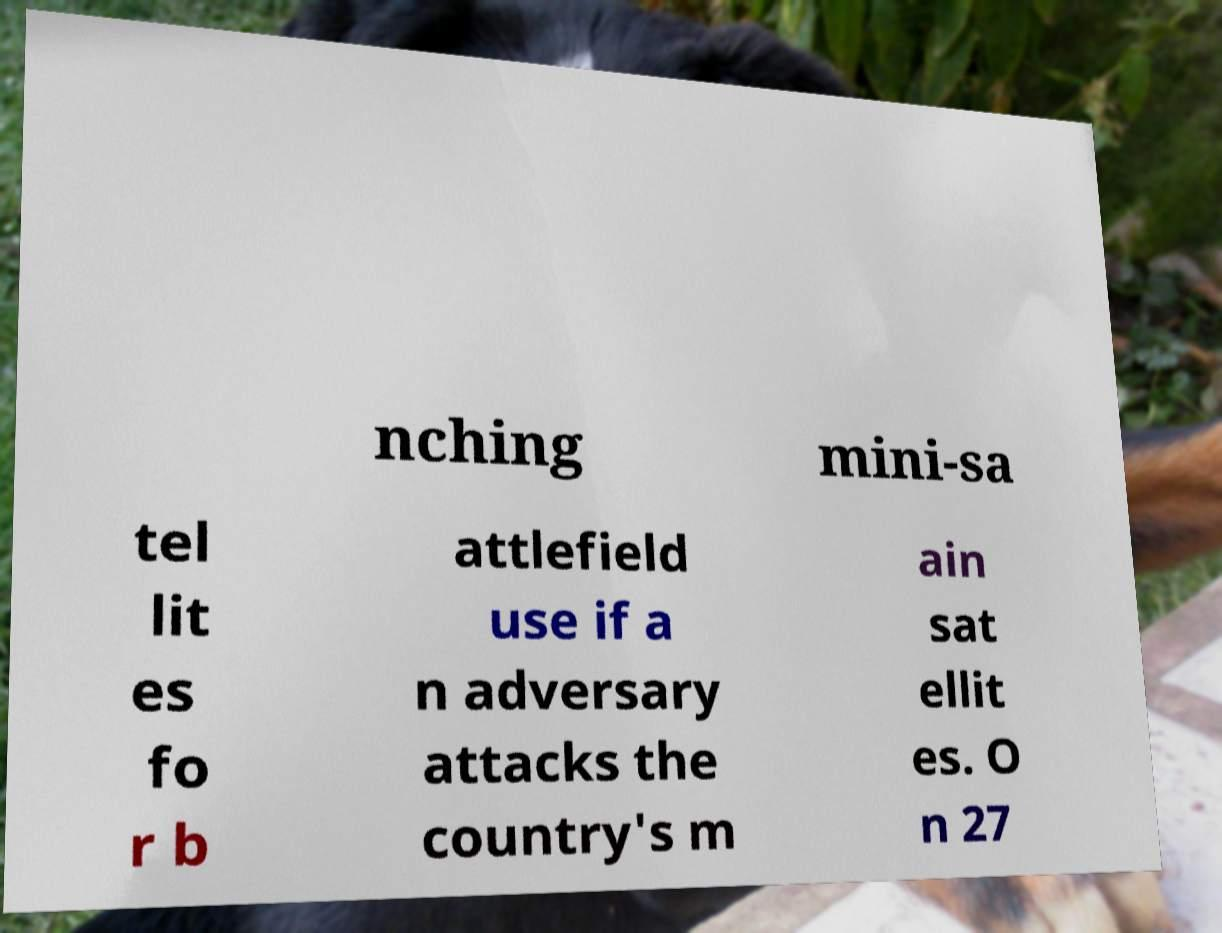Please read and relay the text visible in this image. What does it say? nching mini-sa tel lit es fo r b attlefield use if a n adversary attacks the country's m ain sat ellit es. O n 27 